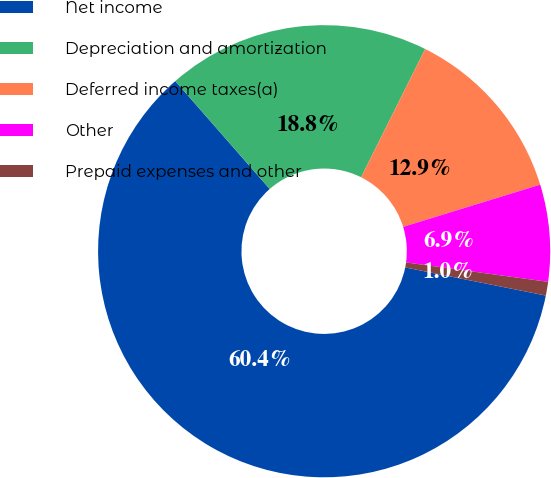Convert chart to OTSL. <chart><loc_0><loc_0><loc_500><loc_500><pie_chart><fcel>Net income<fcel>Depreciation and amortization<fcel>Deferred income taxes(a)<fcel>Other<fcel>Prepaid expenses and other<nl><fcel>60.42%<fcel>18.81%<fcel>12.87%<fcel>6.92%<fcel>0.98%<nl></chart> 